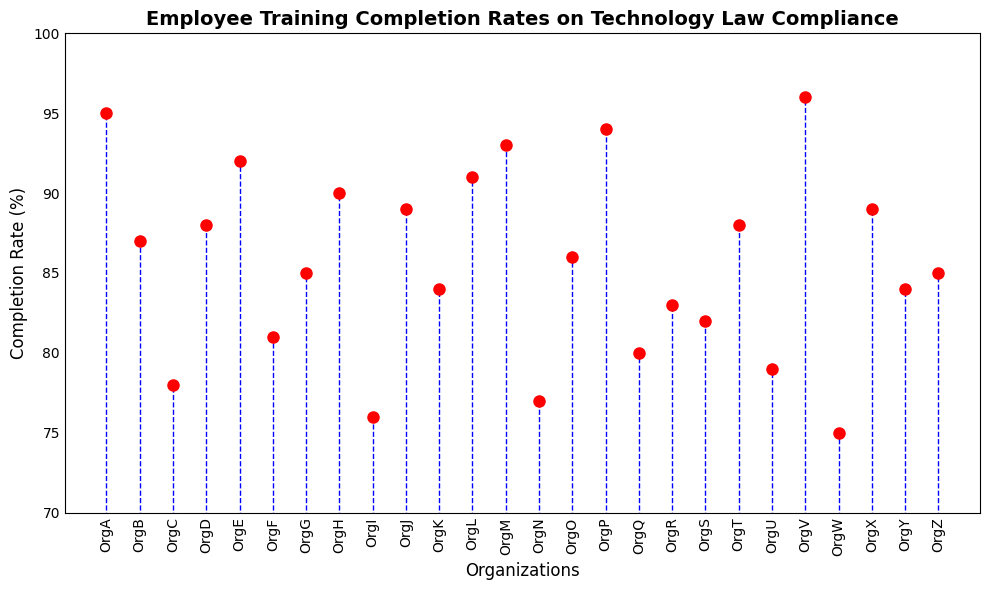What's the completion rate for OrgV? Look at the completion rate next to OrgV on the x-axis; it shows 96%
Answer: 96% Which organization has the lowest completion rate? Identify the organization whose dot is the lowest on the y-axis; it's OrgW with a 75% completion rate
Answer: OrgW How many organizations have a completion rate above 90%? Count the organizations with dots above the 90% mark on the y-axis; there are six such dots
Answer: 6 What is the median completion rate of all organizations? Arrange the completion rates in ascending order and find the middle value; the sorted data is (75, 76, 77, 78, 79, 80, 81, 82, 83, 84, 84, 85, 85, 86, 87, 88, 88, 89, 89, 90, 91, 92, 93, 94, 95, 96), and the median of 26 rates is the average of the 13th and 14th values: (84+86)/2
Answer: 85 Which organizations have completion rates exactly equal to 89%? Look for dots at the 89% level on the y-axis and identify the corresponding organizations on the x-axis; they are OrgJ and OrgX
Answer: OrgJ and OrgX 